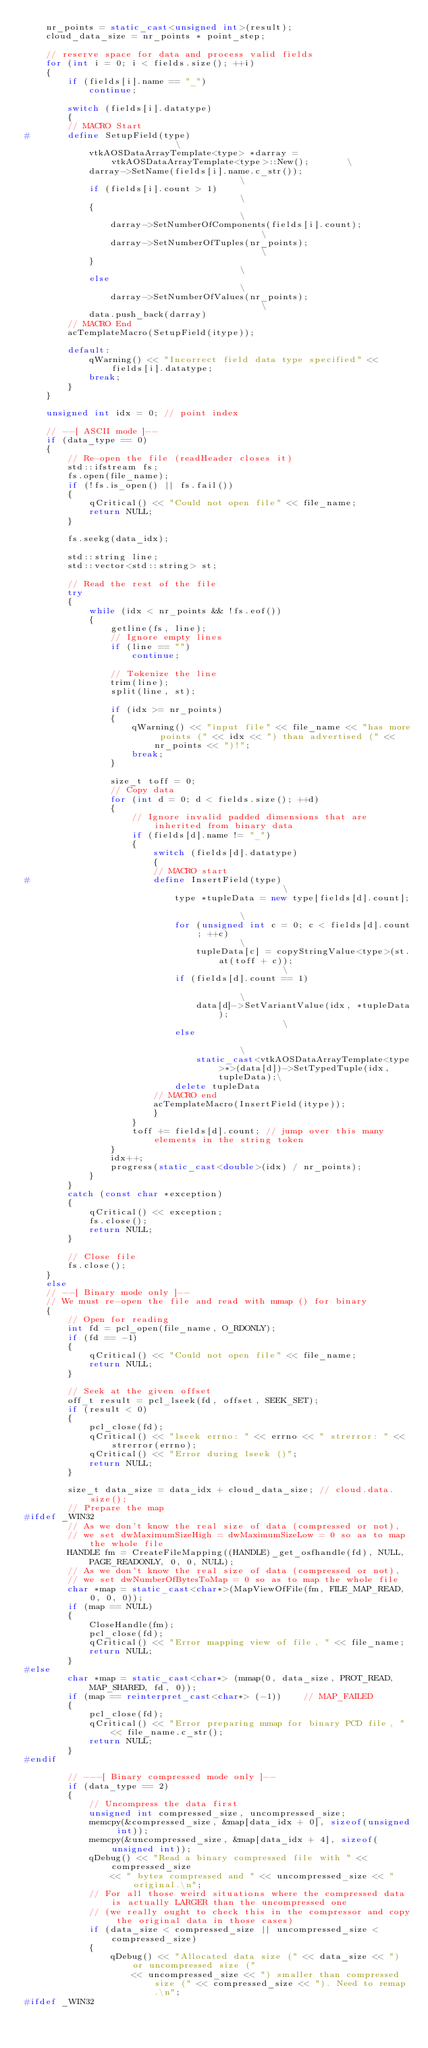<code> <loc_0><loc_0><loc_500><loc_500><_C++_>	nr_points = static_cast<unsigned int>(result);
	cloud_data_size = nr_points * point_step;

	// reserve space for data and process valid fields
	for (int i = 0; i < fields.size(); ++i)
	{
		if (fields[i].name == "_")
			continue;

		switch (fields[i].datatype)
		{
		// MACRO Start
#		define SetupField(type)																	\
			vtkAOSDataArrayTemplate<type> *darray = vtkAOSDataArrayTemplate<type>::New();		\
			darray->SetName(fields[i].name.c_str());											\
			if (fields[i].count > 1)															\
			{																					\
				darray->SetNumberOfComponents(fields[i].count);									\
				darray->SetNumberOfTuples(nr_points);											\
			}																					\
			else																				\
				darray->SetNumberOfValues(nr_points);											\
			data.push_back(darray)
		// MACRO End
		acTemplateMacro(SetupField(itype));

		default:
			qWarning() << "Incorrect field data type specified" << fields[i].datatype;
			break;
		}
	}

	unsigned int idx = 0; // point index

	// --[ ASCII mode ]--
	if (data_type == 0)
	{
		// Re-open the file (readHeader closes it)
		std::ifstream fs;
		fs.open(file_name);
		if (!fs.is_open() || fs.fail())
		{
			qCritical() << "Could not open file" << file_name;
			return NULL;
		}

		fs.seekg(data_idx);

		std::string line;
		std::vector<std::string> st;

		// Read the rest of the file
		try
		{
			while (idx < nr_points && !fs.eof())
			{
				getline(fs, line);
				// Ignore empty lines
				if (line == "")
					continue;

				// Tokenize the line
				trim(line);
				split(line, st);

				if (idx >= nr_points)
				{
					qWarning() << "input file" << file_name << "has more points (" << idx << ") than advertised (" << nr_points << ")!";
					break;
				}

				size_t toff = 0;
				// Copy data
				for (int d = 0; d < fields.size(); ++d)
				{
					// Ignore invalid padded dimensions that are inherited from binary data
					if (fields[d].name != "_")
					{
						switch (fields[d].datatype)
						{
						// MACRO start
#						define InsertField(type) 																	\
							type *tupleData = new type[fields[d].count];											\
							for (unsigned int c = 0; c < fields[d].count; ++c)										\
								tupleData[c] = copyStringValue<type>(st.at(toff + c));								\
							if (fields[d].count == 1)																\
								data[d]->SetVariantValue(idx, *tupleData);											\
							else																					\
								static_cast<vtkAOSDataArrayTemplate<type>*>(data[d])->SetTypedTuple(idx, tupleData);\
							delete tupleData
						// MACRO end
						acTemplateMacro(InsertField(itype));
						}
					}
					toff += fields[d].count; // jump over this many elements in the string token
				}
				idx++;
				progress(static_cast<double>(idx) / nr_points);
			}
		}
		catch (const char *exception)
		{
			qCritical() << exception;
			fs.close();
			return NULL;
		}

		// Close file
		fs.close();
	}
	else
	// --[ Binary mode only ]--
	// We must re-open the file and read with mmap () for binary
	{
		// Open for reading
		int fd = pcl_open(file_name, O_RDONLY);
		if (fd == -1)
		{
			qCritical() << "Could not open file" << file_name;
			return NULL;
		}

		// Seek at the given offset
		off_t result = pcl_lseek(fd, offset, SEEK_SET);
		if (result < 0)
		{
			pcl_close(fd);
			qCritical() << "lseek errno: " << errno << " strerror: " << strerror(errno);
			qCritical() << "Error during lseek ()";
			return NULL;
		}

		size_t data_size = data_idx + cloud_data_size; // cloud.data.size();
		// Prepare the map
#ifdef _WIN32
		// As we don't know the real size of data (compressed or not), 
		// we set dwMaximumSizeHigh = dwMaximumSizeLow = 0 so as to map the whole file
		HANDLE fm = CreateFileMapping((HANDLE)_get_osfhandle(fd), NULL, PAGE_READONLY, 0, 0, NULL);
		// As we don't know the real size of data (compressed or not), 
		// we set dwNumberOfBytesToMap = 0 so as to map the whole file
		char *map = static_cast<char*>(MapViewOfFile(fm, FILE_MAP_READ, 0, 0, 0));
		if (map == NULL)
		{
			CloseHandle(fm);
			pcl_close(fd);
			qCritical() << "Error mapping view of file, " << file_name;
			return NULL;
		}
#else
		char *map = static_cast<char*> (mmap(0, data_size, PROT_READ, MAP_SHARED, fd, 0));
		if (map == reinterpret_cast<char*> (-1))    // MAP_FAILED
		{
			pcl_close(fd);
			qCritical() << "Error preparing mmap for binary PCD file, " << file_name.c_str();
			return NULL;
		}
#endif

		// ---[ Binary compressed mode only ]--
		if (data_type == 2)
		{
			// Uncompress the data first
			unsigned int compressed_size, uncompressed_size;
			memcpy(&compressed_size, &map[data_idx + 0], sizeof(unsigned int));
			memcpy(&uncompressed_size, &map[data_idx + 4], sizeof(unsigned int));
			qDebug() << "Read a binary compressed file with " << compressed_size
				<< " bytes compressed and " << uncompressed_size << " original.\n";
			// For all those weird situations where the compressed data is actually LARGER than the uncompressed one
			// (we really ought to check this in the compressor and copy the original data in those cases)
			if (data_size < compressed_size || uncompressed_size < compressed_size)
			{
				qDebug() << "Allocated data size (" << data_size << ") or uncompressed size ("
					<< uncompressed_size << ") smaller than compressed size (" << compressed_size << "). Need to remap.\n";
#ifdef _WIN32</code> 